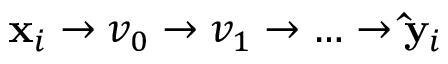<formula> <loc_0><loc_0><loc_500><loc_500>x _ { i } \rightarrow v _ { 0 } \rightarrow v _ { 1 } \rightarrow \hdots \rightarrow \hat { y } _ { i }</formula> 